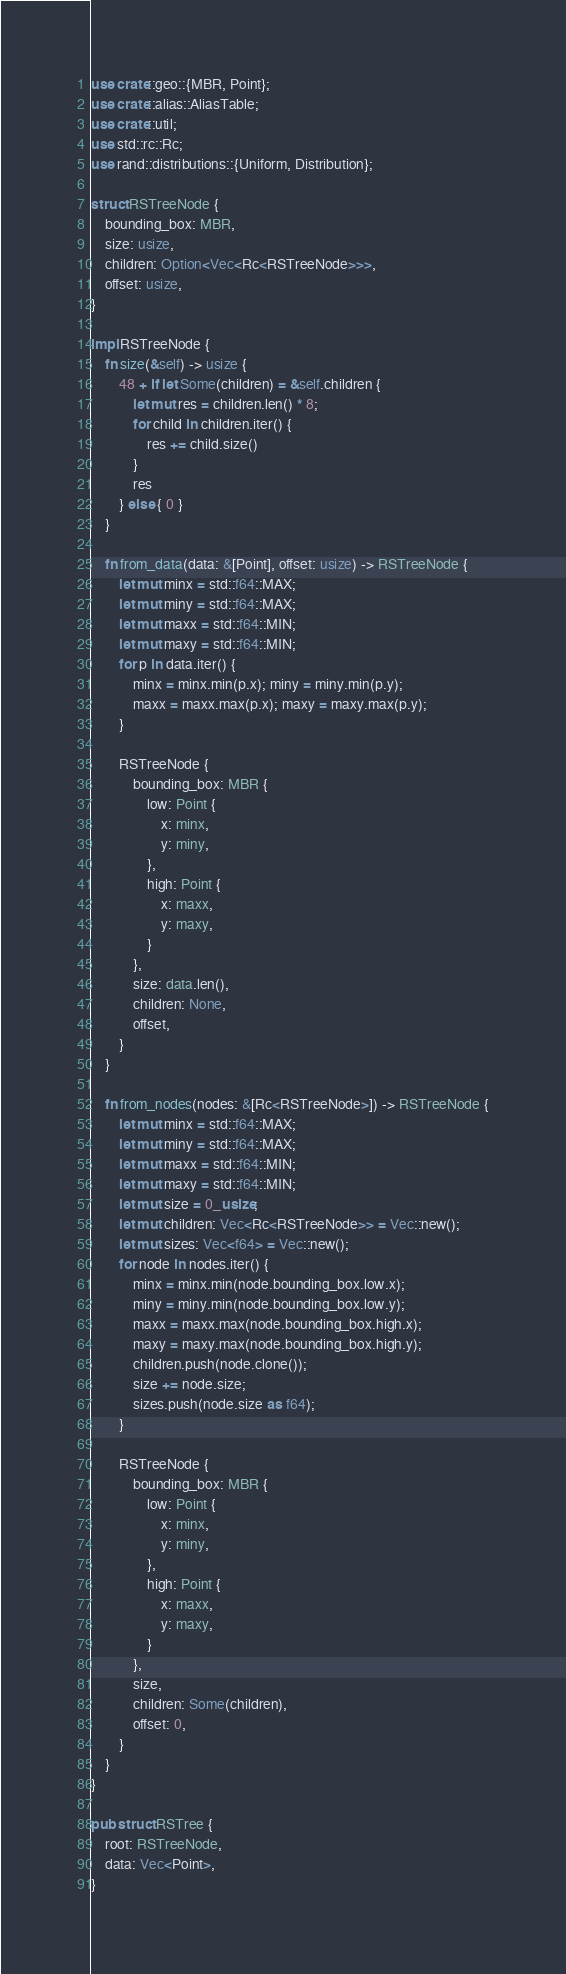Convert code to text. <code><loc_0><loc_0><loc_500><loc_500><_Rust_>use crate::geo::{MBR, Point};
use crate::alias::AliasTable;
use crate::util;
use std::rc::Rc;
use rand::distributions::{Uniform, Distribution};

struct RSTreeNode {
    bounding_box: MBR,
    size: usize,
    children: Option<Vec<Rc<RSTreeNode>>>,
    offset: usize,
}

impl RSTreeNode {
    fn size(&self) -> usize {
        48 + if let Some(children) = &self.children {
            let mut res = children.len() * 8;
            for child in children.iter() {
                res += child.size()
            }
            res
        } else { 0 }
    }

    fn from_data(data: &[Point], offset: usize) -> RSTreeNode {
        let mut minx = std::f64::MAX;
        let mut miny = std::f64::MAX;
        let mut maxx = std::f64::MIN;
        let mut maxy = std::f64::MIN;
        for p in data.iter() {
            minx = minx.min(p.x); miny = miny.min(p.y);
            maxx = maxx.max(p.x); maxy = maxy.max(p.y);
        }

        RSTreeNode {
            bounding_box: MBR {
                low: Point {
                    x: minx,
                    y: miny,
                },
                high: Point {
                    x: maxx,
                    y: maxy,
                }
            },
            size: data.len(),
            children: None,
            offset,
        }
    }

    fn from_nodes(nodes: &[Rc<RSTreeNode>]) -> RSTreeNode {
        let mut minx = std::f64::MAX;
        let mut miny = std::f64::MAX;
        let mut maxx = std::f64::MIN;
        let mut maxy = std::f64::MIN;
        let mut size = 0_usize;
        let mut children: Vec<Rc<RSTreeNode>> = Vec::new();
        let mut sizes: Vec<f64> = Vec::new();
        for node in nodes.iter() {
            minx = minx.min(node.bounding_box.low.x);
            miny = miny.min(node.bounding_box.low.y);
            maxx = maxx.max(node.bounding_box.high.x);
            maxy = maxy.max(node.bounding_box.high.y);
            children.push(node.clone());
            size += node.size;
            sizes.push(node.size as f64);
        }

        RSTreeNode {
            bounding_box: MBR {
                low: Point {
                    x: minx,
                    y: miny,
                },
                high: Point {
                    x: maxx,
                    y: maxy,
                }
            },
            size,
            children: Some(children),
            offset: 0,
        }
    }
}

pub struct RSTree {
    root: RSTreeNode,
    data: Vec<Point>,
}
</code> 